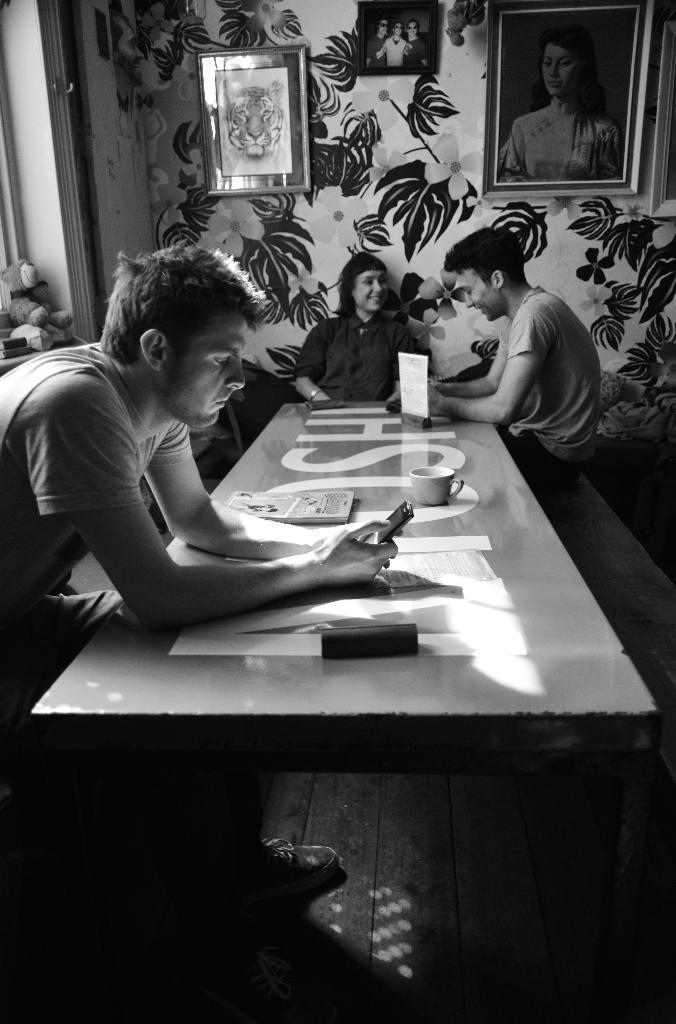Can you describe this image briefly? In this image there are group of people sitting in chairs and on table there is cup,book,mobile ,pouch,card ,and in the back ground there are frames attached to wall, teddy bear in a window. 